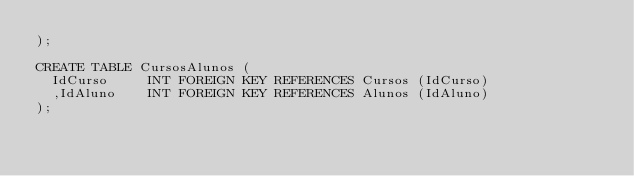Convert code to text. <code><loc_0><loc_0><loc_500><loc_500><_SQL_>);

CREATE TABLE CursosAlunos (
	IdCurso			INT FOREIGN KEY REFERENCES Cursos (IdCurso)
	,IdAluno		INT FOREIGN KEY REFERENCES Alunos (IdAluno)
);

</code> 